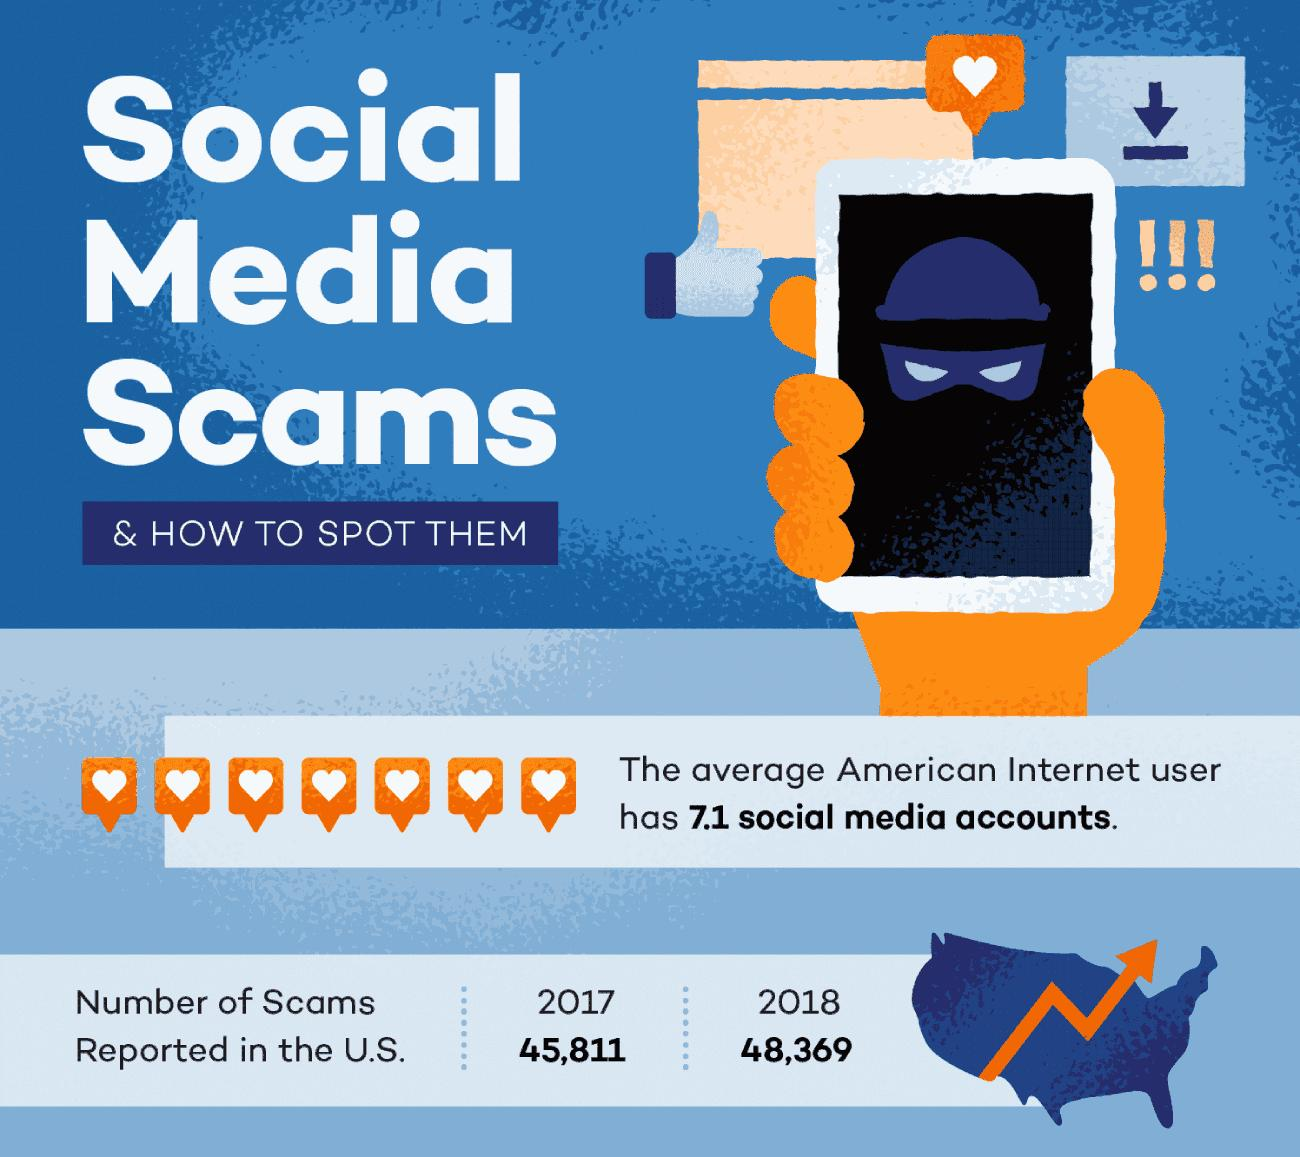Indicate a few pertinent items in this graphic. In the United States in 2018, a total of 48,369 scams were reported. In 2017, a total of 45,811 scams were reported in the United States. 